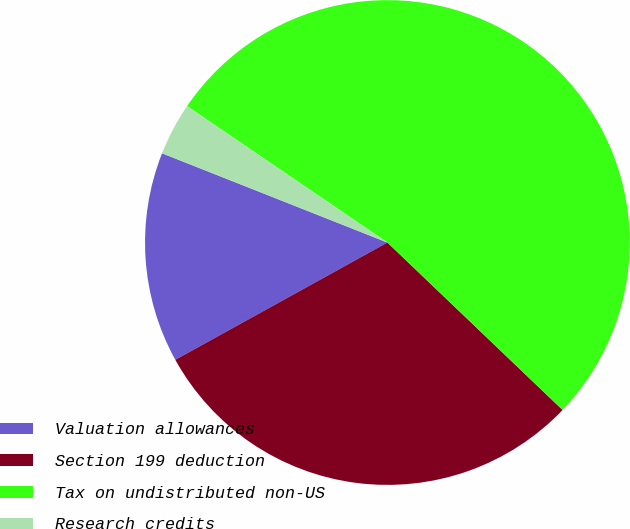<chart> <loc_0><loc_0><loc_500><loc_500><pie_chart><fcel>Valuation allowances<fcel>Section 199 deduction<fcel>Tax on undistributed non-US<fcel>Research credits<nl><fcel>14.04%<fcel>29.82%<fcel>52.63%<fcel>3.51%<nl></chart> 